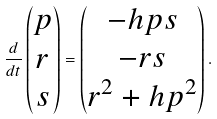Convert formula to latex. <formula><loc_0><loc_0><loc_500><loc_500>\frac { d } { d t } \begin{pmatrix} p \\ r \\ s \end{pmatrix} = \begin{pmatrix} - h p s \\ - r s \\ r ^ { 2 } + h p ^ { 2 } \end{pmatrix} .</formula> 